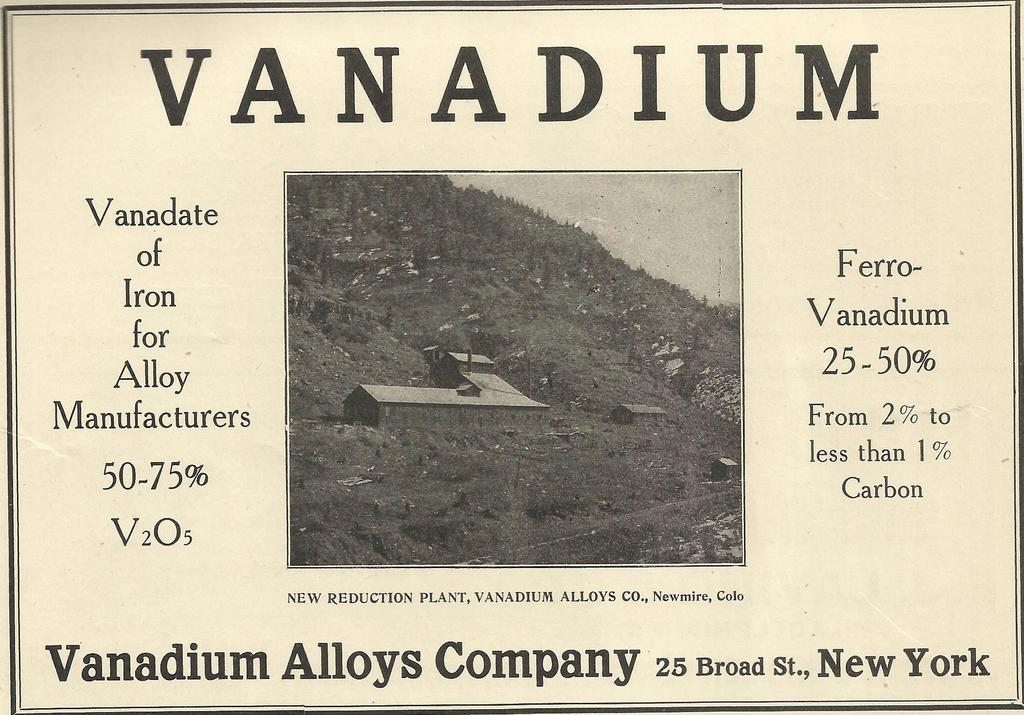What is the color scheme of the image? The image is a black and white picture. What is the main subject of the image? The picture depicts a hill with homes in front. Is there any text associated with the image? Yes, there is text surrounding the picture. How is the image presented? The image is on a poster. Can you tell me how many bats are flying around the hill in the image? There are no bats present in the image; it depicts a hill with homes in front. What type of game is being played on the hill in the image? There is no game being played in the image; it shows a hill with homes in front. 